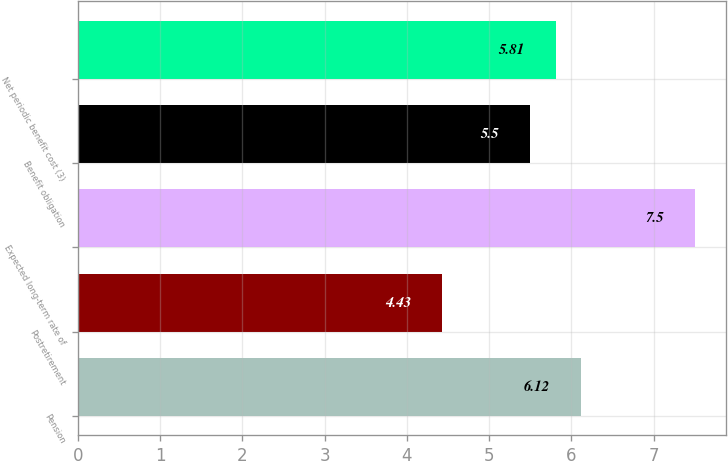<chart> <loc_0><loc_0><loc_500><loc_500><bar_chart><fcel>Pension<fcel>Postretirement<fcel>Expected long-term rate of<fcel>Benefit obligation<fcel>Net periodic benefit cost (3)<nl><fcel>6.12<fcel>4.43<fcel>7.5<fcel>5.5<fcel>5.81<nl></chart> 